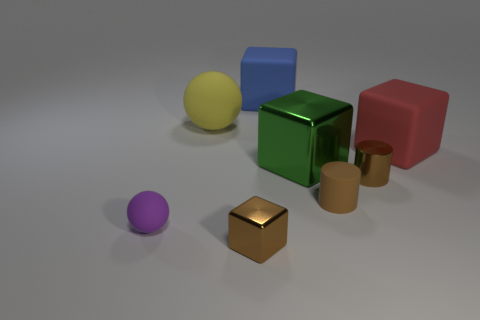There is a tiny thing that is the same shape as the big green metallic object; what material is it?
Make the answer very short. Metal. There is a green object that is the same size as the red rubber object; what is it made of?
Your answer should be compact. Metal. How many brown things are small shiny cubes or small things?
Give a very brief answer. 3. What is the color of the object that is both behind the tiny brown metallic block and in front of the brown rubber cylinder?
Provide a succinct answer. Purple. Is the material of the brown object that is to the left of the big blue block the same as the sphere that is in front of the red rubber block?
Your answer should be very brief. No. Is the number of shiny blocks in front of the brown matte object greater than the number of purple rubber things that are right of the tiny brown block?
Offer a terse response. Yes. What is the shape of the yellow rubber object that is the same size as the blue object?
Provide a short and direct response. Sphere. How many objects are either big rubber things or cubes that are behind the yellow ball?
Your response must be concise. 3. Do the small metal cylinder and the tiny matte cylinder have the same color?
Provide a short and direct response. Yes. What number of tiny brown cubes are behind the large shiny thing?
Make the answer very short. 0. 